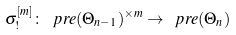<formula> <loc_0><loc_0><loc_500><loc_500>\sigma ^ { [ m ] } _ { ! } \colon \ p r e ( \Theta _ { n - 1 } ) ^ { \times m } \to \ p r e ( \Theta _ { n } )</formula> 